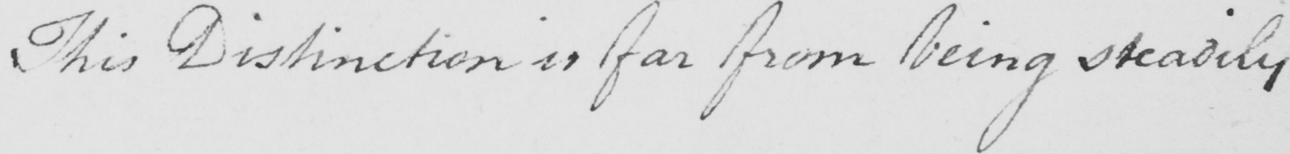What text is written in this handwritten line? This Distinction is far from being steadily 